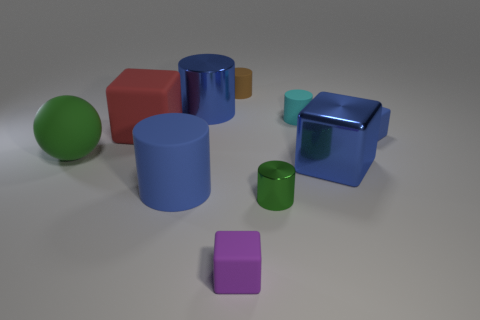If you had to guess, what purpose do these objects serve? These objects could serve educational purposes, such as toys for learning about shapes and colors. They might also be components of a display or a setup for a visual demonstration, given their arranged and simplistic nature. 